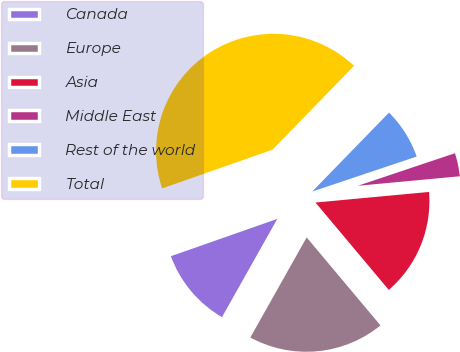Convert chart to OTSL. <chart><loc_0><loc_0><loc_500><loc_500><pie_chart><fcel>Canada<fcel>Europe<fcel>Asia<fcel>Middle East<fcel>Rest of the world<fcel>Total<nl><fcel>11.47%<fcel>19.27%<fcel>15.37%<fcel>3.67%<fcel>7.57%<fcel>42.65%<nl></chart> 